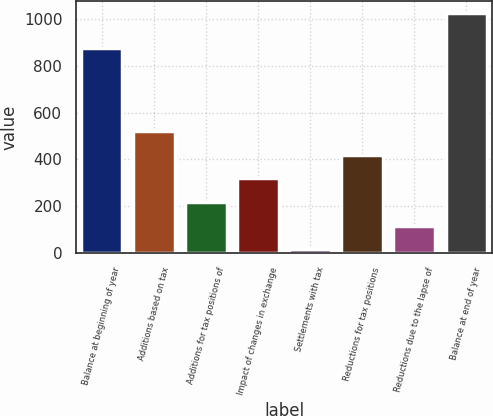<chart> <loc_0><loc_0><loc_500><loc_500><bar_chart><fcel>Balance at beginning of year<fcel>Additions based on tax<fcel>Additions for tax positions of<fcel>Impact of changes in exchange<fcel>Settlements with tax<fcel>Reductions for tax positions<fcel>Reductions due to the lapse of<fcel>Balance at end of year<nl><fcel>877<fcel>521<fcel>218<fcel>319<fcel>16<fcel>420<fcel>117<fcel>1026<nl></chart> 